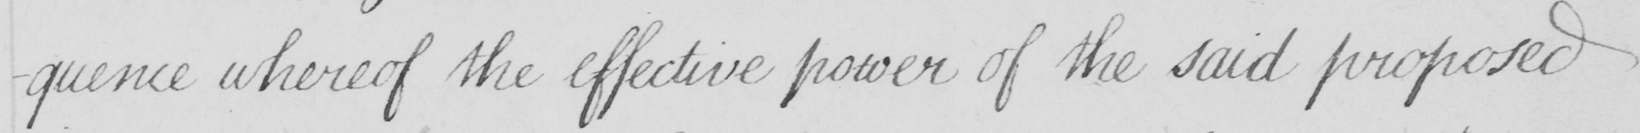What is written in this line of handwriting? -quence whereof the effective power of the said proposed 